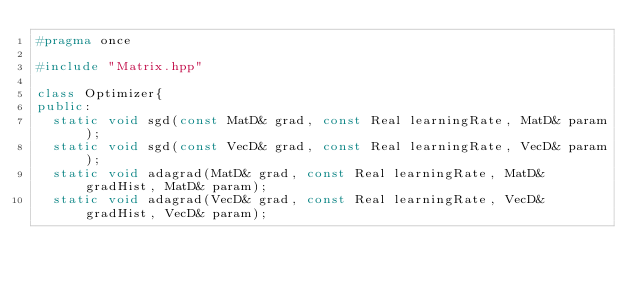<code> <loc_0><loc_0><loc_500><loc_500><_C++_>#pragma once

#include "Matrix.hpp"

class Optimizer{
public:
  static void sgd(const MatD& grad, const Real learningRate, MatD& param);
  static void sgd(const VecD& grad, const Real learningRate, VecD& param);
  static void adagrad(MatD& grad, const Real learningRate, MatD& gradHist, MatD& param);
  static void adagrad(VecD& grad, const Real learningRate, VecD& gradHist, VecD& param);</code> 